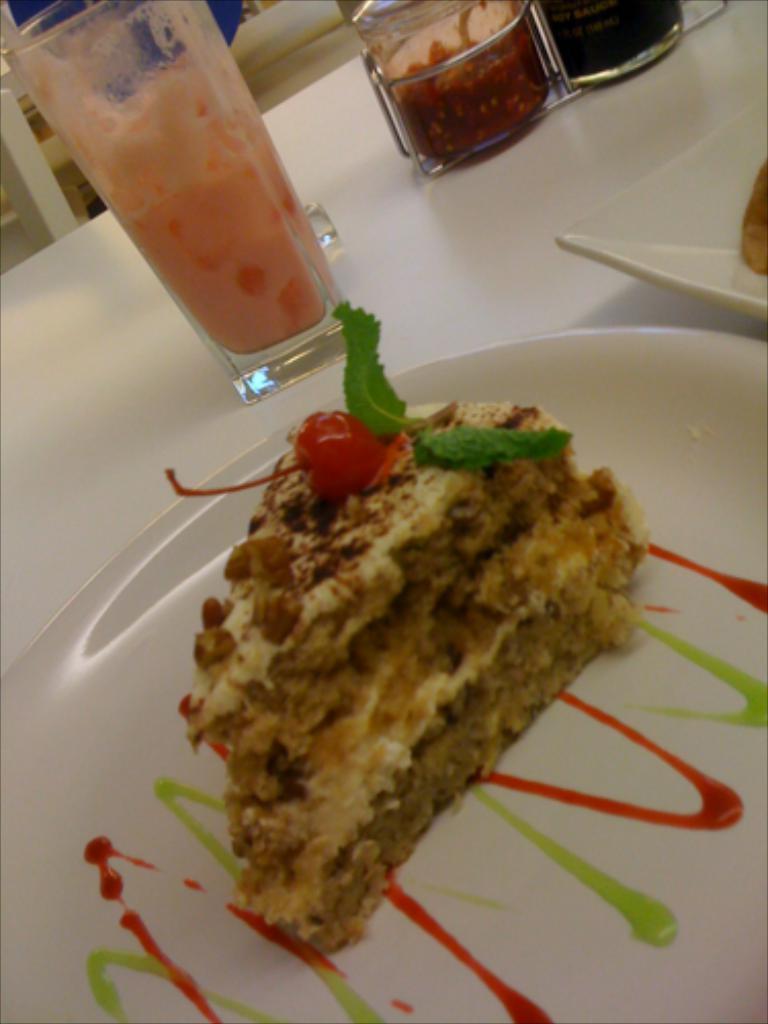Could you give a brief overview of what you see in this image? In this image there is a pastry in a plate. Beside the plate there is another plate with food item on it. There are glasses on the table. 